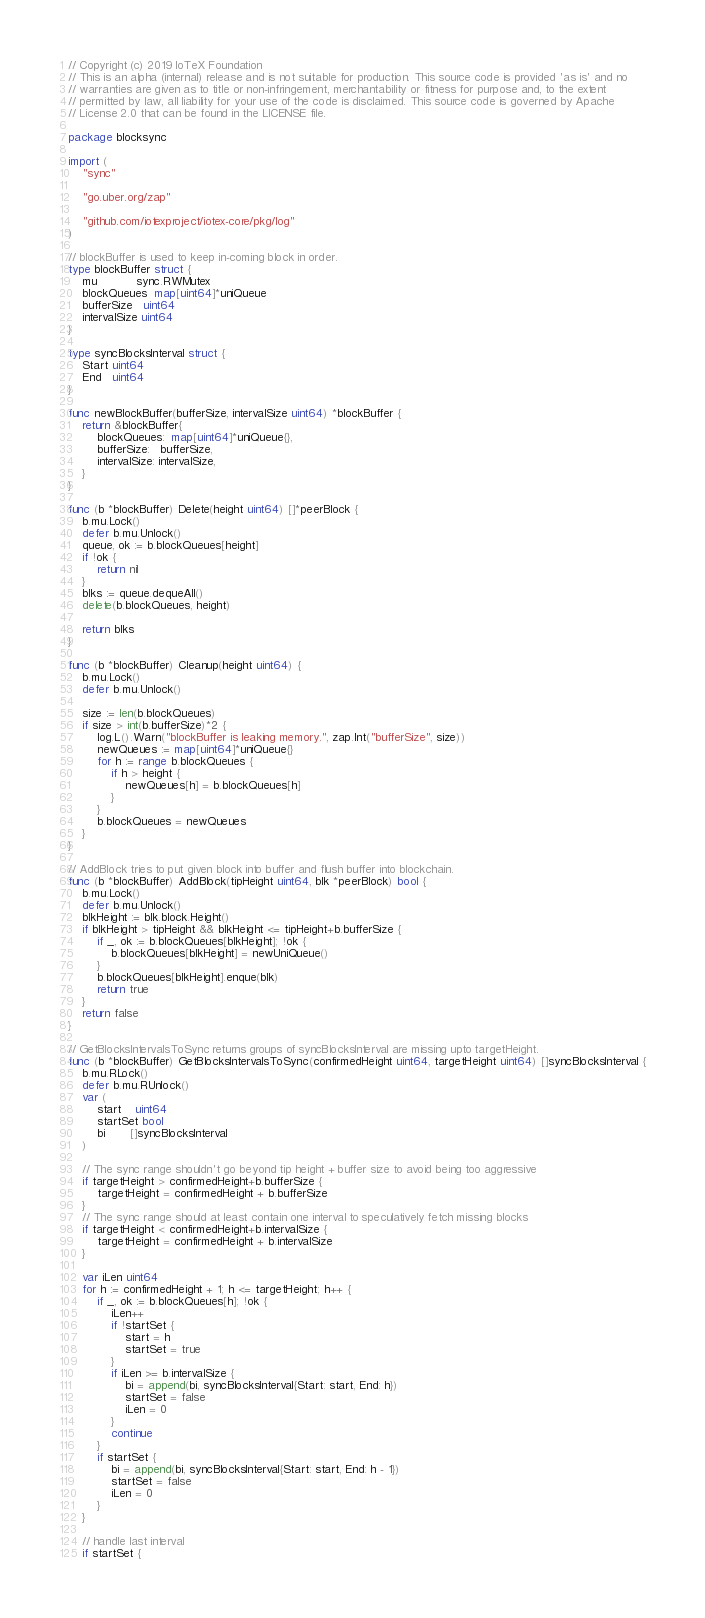Convert code to text. <code><loc_0><loc_0><loc_500><loc_500><_Go_>// Copyright (c) 2019 IoTeX Foundation
// This is an alpha (internal) release and is not suitable for production. This source code is provided 'as is' and no
// warranties are given as to title or non-infringement, merchantability or fitness for purpose and, to the extent
// permitted by law, all liability for your use of the code is disclaimed. This source code is governed by Apache
// License 2.0 that can be found in the LICENSE file.

package blocksync

import (
	"sync"

	"go.uber.org/zap"

	"github.com/iotexproject/iotex-core/pkg/log"
)

// blockBuffer is used to keep in-coming block in order.
type blockBuffer struct {
	mu           sync.RWMutex
	blockQueues  map[uint64]*uniQueue
	bufferSize   uint64
	intervalSize uint64
}

type syncBlocksInterval struct {
	Start uint64
	End   uint64
}

func newBlockBuffer(bufferSize, intervalSize uint64) *blockBuffer {
	return &blockBuffer{
		blockQueues:  map[uint64]*uniQueue{},
		bufferSize:   bufferSize,
		intervalSize: intervalSize,
	}
}

func (b *blockBuffer) Delete(height uint64) []*peerBlock {
	b.mu.Lock()
	defer b.mu.Unlock()
	queue, ok := b.blockQueues[height]
	if !ok {
		return nil
	}
	blks := queue.dequeAll()
	delete(b.blockQueues, height)

	return blks
}

func (b *blockBuffer) Cleanup(height uint64) {
	b.mu.Lock()
	defer b.mu.Unlock()

	size := len(b.blockQueues)
	if size > int(b.bufferSize)*2 {
		log.L().Warn("blockBuffer is leaking memory.", zap.Int("bufferSize", size))
		newQueues := map[uint64]*uniQueue{}
		for h := range b.blockQueues {
			if h > height {
				newQueues[h] = b.blockQueues[h]
			}
		}
		b.blockQueues = newQueues
	}
}

// AddBlock tries to put given block into buffer and flush buffer into blockchain.
func (b *blockBuffer) AddBlock(tipHeight uint64, blk *peerBlock) bool {
	b.mu.Lock()
	defer b.mu.Unlock()
	blkHeight := blk.block.Height()
	if blkHeight > tipHeight && blkHeight <= tipHeight+b.bufferSize {
		if _, ok := b.blockQueues[blkHeight]; !ok {
			b.blockQueues[blkHeight] = newUniQueue()
		}
		b.blockQueues[blkHeight].enque(blk)
		return true
	}
	return false
}

// GetBlocksIntervalsToSync returns groups of syncBlocksInterval are missing upto targetHeight.
func (b *blockBuffer) GetBlocksIntervalsToSync(confirmedHeight uint64, targetHeight uint64) []syncBlocksInterval {
	b.mu.RLock()
	defer b.mu.RUnlock()
	var (
		start    uint64
		startSet bool
		bi       []syncBlocksInterval
	)

	// The sync range shouldn't go beyond tip height + buffer size to avoid being too aggressive
	if targetHeight > confirmedHeight+b.bufferSize {
		targetHeight = confirmedHeight + b.bufferSize
	}
	// The sync range should at least contain one interval to speculatively fetch missing blocks
	if targetHeight < confirmedHeight+b.intervalSize {
		targetHeight = confirmedHeight + b.intervalSize
	}

	var iLen uint64
	for h := confirmedHeight + 1; h <= targetHeight; h++ {
		if _, ok := b.blockQueues[h]; !ok {
			iLen++
			if !startSet {
				start = h
				startSet = true
			}
			if iLen >= b.intervalSize {
				bi = append(bi, syncBlocksInterval{Start: start, End: h})
				startSet = false
				iLen = 0
			}
			continue
		}
		if startSet {
			bi = append(bi, syncBlocksInterval{Start: start, End: h - 1})
			startSet = false
			iLen = 0
		}
	}

	// handle last interval
	if startSet {</code> 